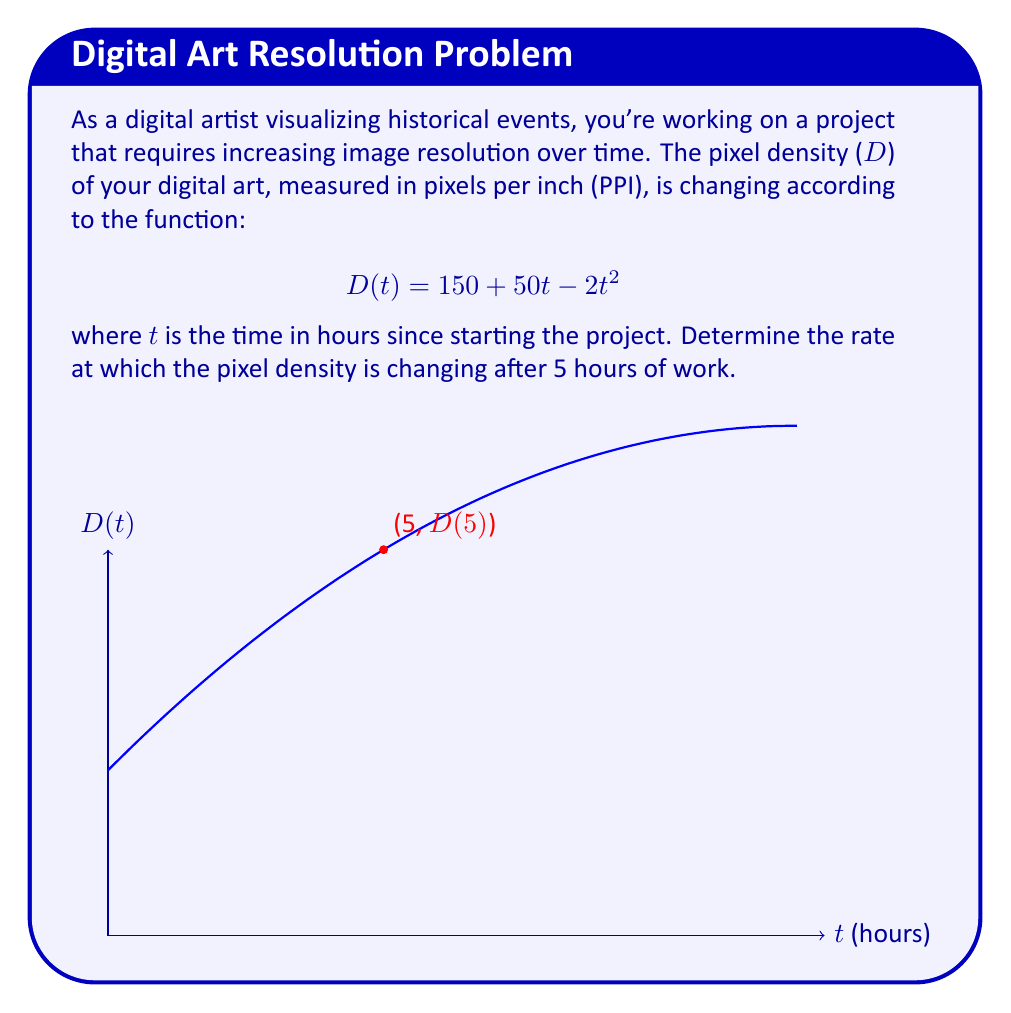Show me your answer to this math problem. To find the rate of change of pixel density at t = 5 hours, we need to calculate the derivative of D(t) and then evaluate it at t = 5.

Step 1: Find the derivative of D(t).
$$D(t) = 150 + 50t - 2t^2$$
$$\frac{d}{dt}D(t) = \frac{d}{dt}(150) + \frac{d}{dt}(50t) - \frac{d}{dt}(2t^2)$$
$$D'(t) = 0 + 50 - 4t$$

Step 2: Simplify the derivative.
$$D'(t) = 50 - 4t$$

Step 3: Evaluate D'(t) at t = 5.
$$D'(5) = 50 - 4(5)$$
$$D'(5) = 50 - 20$$
$$D'(5) = 30$$

The rate of change of pixel density after 5 hours is 30 PPI per hour.
Answer: 30 PPI/hour 